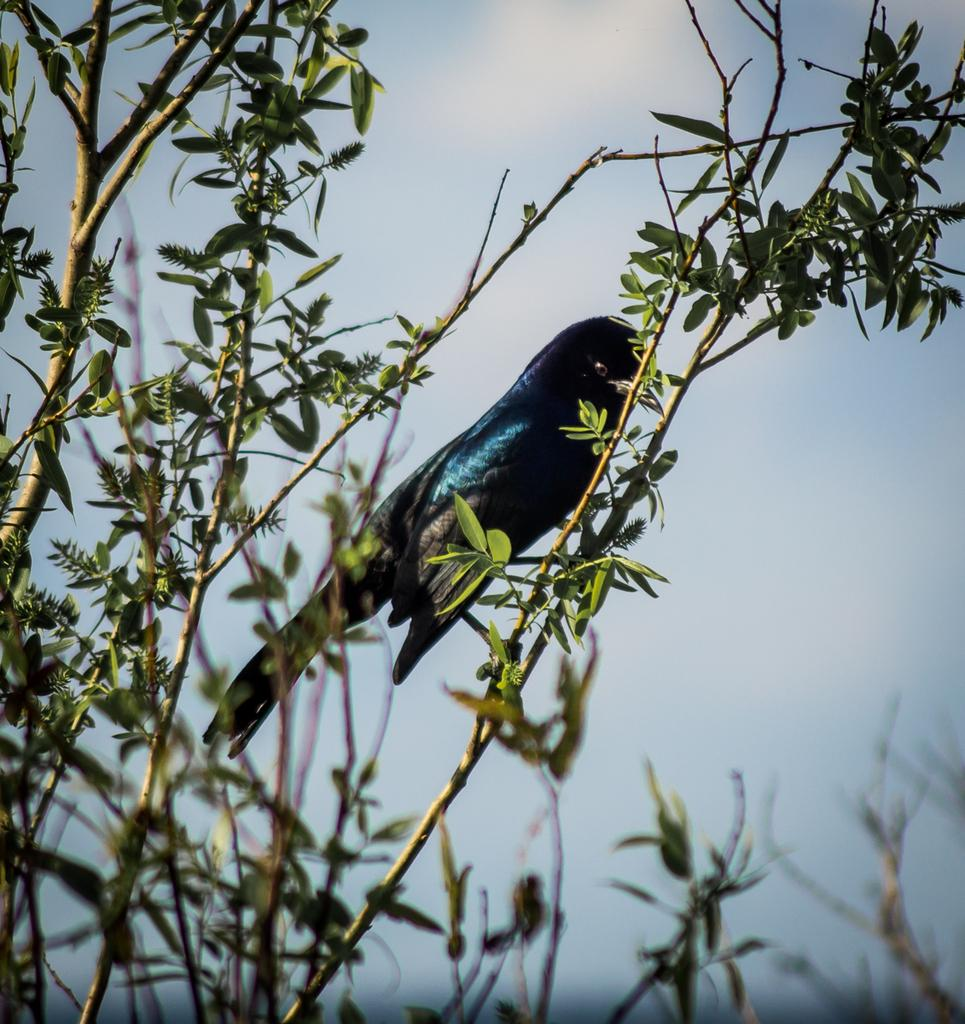What type of animal can be seen in the image? There is a bird in the image. Where is the bird located? The bird is on a branch of a tree. What can be seen around the bird? There are leaves and branches around the bird. What is visible in the background of the image? The sky is visible in the background of the image. What type of fang can be seen on the bird in the image? There are no fangs present on the bird in the image; it is a bird, not a creature with fangs. Can you see a rabbit hopping near the bird in the image? There is no rabbit present in the image; it only features a bird on a tree branch. 